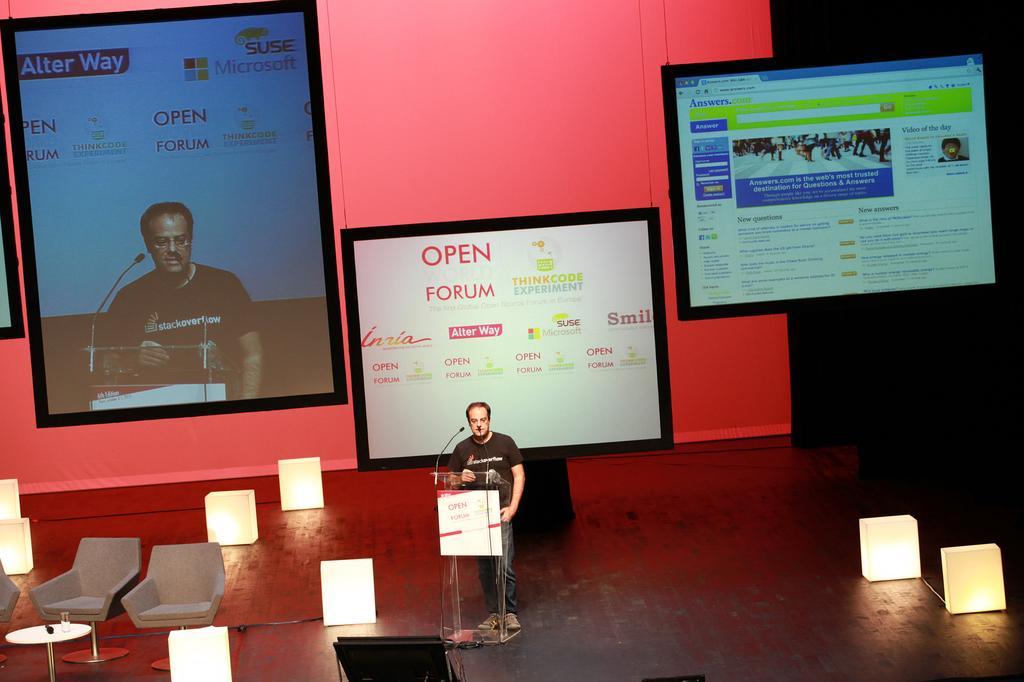How would you summarize this image in a sentence or two? This is looking like a stage. Here I can see a man standing in front of a podium. In front of him there is a microphone is attached to this podium. On the left side there are three empty words and few light boxes are placed on the stage. In the background there is a screen and two boards are attach a banner which is in red color. 